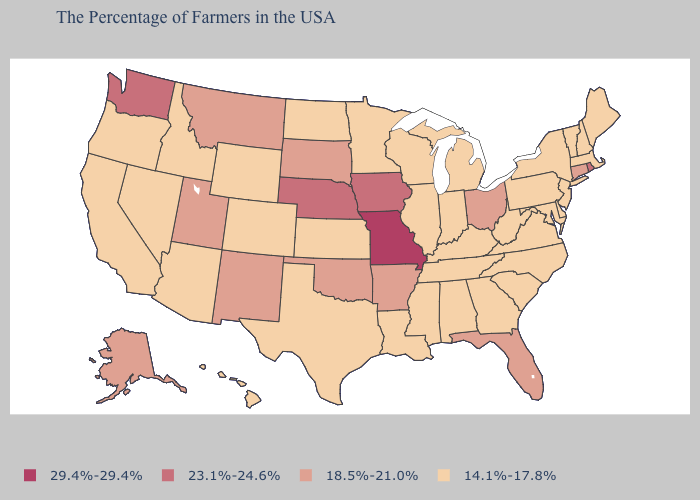Is the legend a continuous bar?
Be succinct. No. Name the states that have a value in the range 14.1%-17.8%?
Quick response, please. Maine, Massachusetts, New Hampshire, Vermont, New York, New Jersey, Delaware, Maryland, Pennsylvania, Virginia, North Carolina, South Carolina, West Virginia, Georgia, Michigan, Kentucky, Indiana, Alabama, Tennessee, Wisconsin, Illinois, Mississippi, Louisiana, Minnesota, Kansas, Texas, North Dakota, Wyoming, Colorado, Arizona, Idaho, Nevada, California, Oregon, Hawaii. Among the states that border Connecticut , which have the highest value?
Concise answer only. Rhode Island. Does the map have missing data?
Give a very brief answer. No. Name the states that have a value in the range 23.1%-24.6%?
Be succinct. Rhode Island, Iowa, Nebraska, Washington. What is the value of Tennessee?
Give a very brief answer. 14.1%-17.8%. Does Oklahoma have the lowest value in the South?
Short answer required. No. Does Minnesota have the lowest value in the USA?
Give a very brief answer. Yes. Name the states that have a value in the range 23.1%-24.6%?
Keep it brief. Rhode Island, Iowa, Nebraska, Washington. What is the highest value in the MidWest ?
Keep it brief. 29.4%-29.4%. Does the first symbol in the legend represent the smallest category?
Quick response, please. No. What is the highest value in the South ?
Answer briefly. 18.5%-21.0%. What is the value of California?
Be succinct. 14.1%-17.8%. Does Colorado have the lowest value in the USA?
Concise answer only. Yes. Name the states that have a value in the range 29.4%-29.4%?
Give a very brief answer. Missouri. 